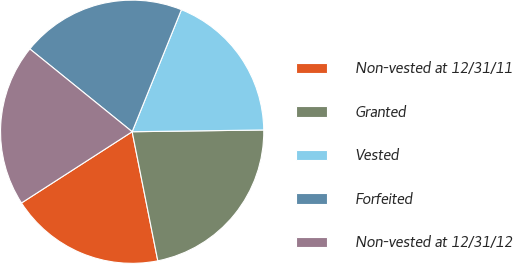<chart> <loc_0><loc_0><loc_500><loc_500><pie_chart><fcel>Non-vested at 12/31/11<fcel>Granted<fcel>Vested<fcel>Forfeited<fcel>Non-vested at 12/31/12<nl><fcel>19.02%<fcel>22.09%<fcel>18.68%<fcel>20.28%<fcel>19.93%<nl></chart> 